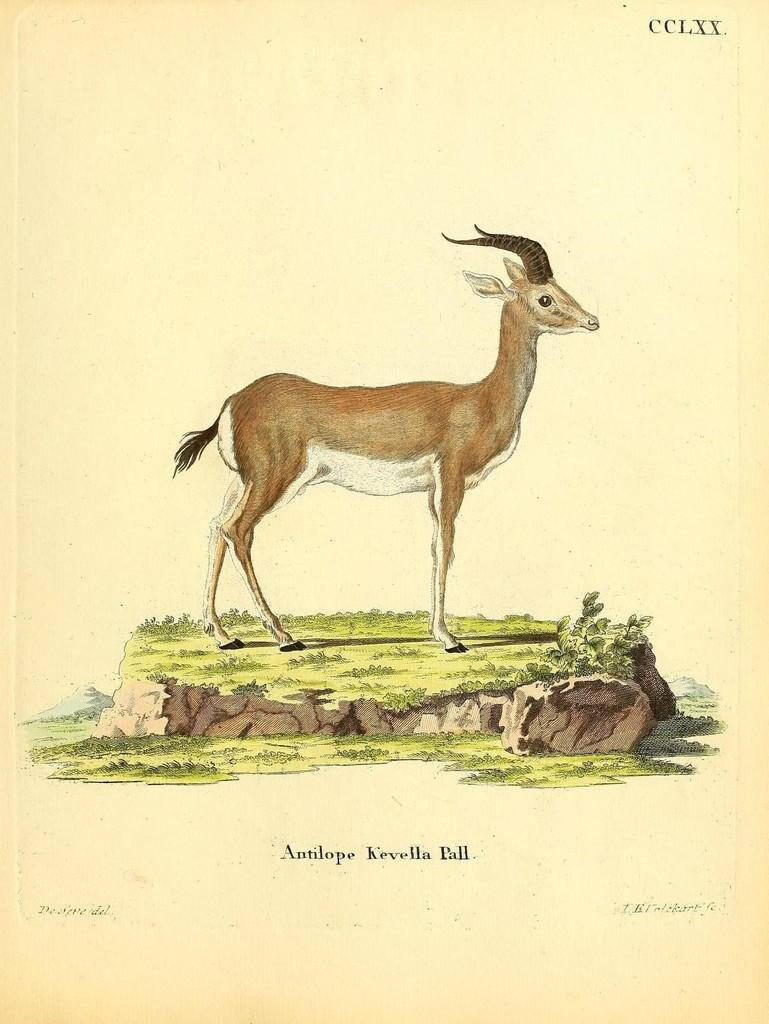What is featured on the poster in the image? There is a poster with text in the image. Can you describe the animal in the image? The animal is standing on a tree stump. What day of the week is depicted on the poster? There is no indication of a specific day of the week on the poster; it only features text. What type of brake is attached to the animal's leg in the image? There is no brake present in the image; the animal is standing on a tree stump. 